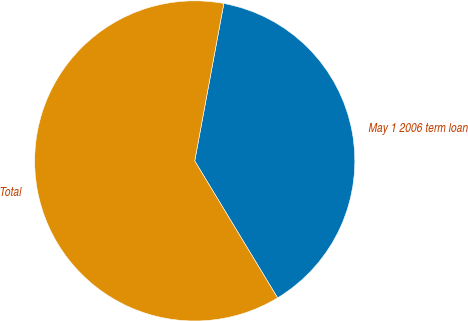Convert chart. <chart><loc_0><loc_0><loc_500><loc_500><pie_chart><fcel>May 1 2006 term loan<fcel>Total<nl><fcel>38.43%<fcel>61.57%<nl></chart> 